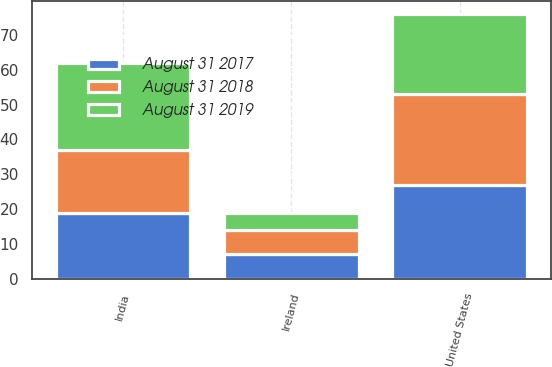Convert chart to OTSL. <chart><loc_0><loc_0><loc_500><loc_500><stacked_bar_chart><ecel><fcel>United States<fcel>India<fcel>Ireland<nl><fcel>August 31 2018<fcel>26<fcel>18<fcel>7<nl><fcel>August 31 2017<fcel>27<fcel>19<fcel>7<nl><fcel>August 31 2019<fcel>23<fcel>25<fcel>5<nl></chart> 